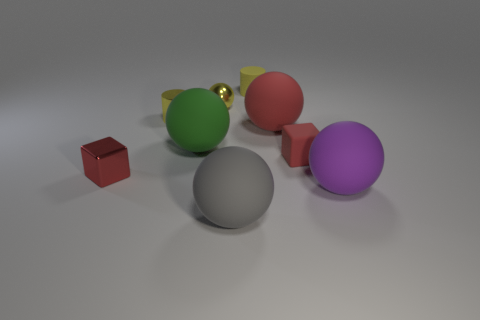What is the material of the small sphere that is the same color as the tiny matte cylinder?
Your answer should be compact. Metal. There is a yellow metal cylinder; is its size the same as the matte sphere that is to the left of the gray rubber thing?
Your response must be concise. No. How many things are either rubber spheres that are on the left side of the big purple rubber object or tiny metal spheres?
Provide a succinct answer. 4. There is a tiny rubber object that is in front of the small yellow metal cylinder; what is its shape?
Your answer should be very brief. Cube. Are there an equal number of small matte objects on the left side of the tiny red shiny cube and small yellow things that are to the right of the small yellow matte cylinder?
Give a very brief answer. Yes. There is a rubber sphere that is on the right side of the large gray ball and on the left side of the purple rubber sphere; what is its color?
Your answer should be compact. Red. There is a tiny red thing that is to the left of the block right of the tiny rubber cylinder; what is it made of?
Offer a terse response. Metal. Is the size of the shiny cylinder the same as the green ball?
Your answer should be very brief. No. What number of small objects are either yellow shiny spheres or green metal blocks?
Provide a short and direct response. 1. What number of tiny metal balls are on the left side of the gray matte thing?
Your answer should be very brief. 1. 